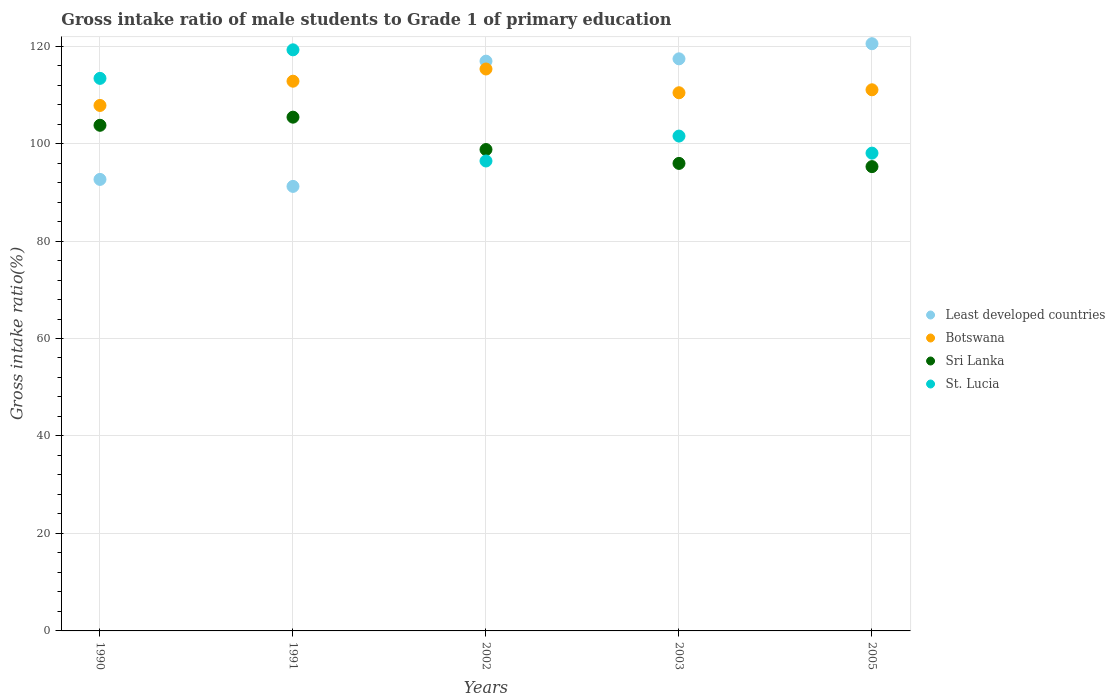How many different coloured dotlines are there?
Provide a succinct answer. 4. Is the number of dotlines equal to the number of legend labels?
Your answer should be very brief. Yes. What is the gross intake ratio in Sri Lanka in 1991?
Your answer should be compact. 105.41. Across all years, what is the maximum gross intake ratio in St. Lucia?
Make the answer very short. 119.23. Across all years, what is the minimum gross intake ratio in St. Lucia?
Provide a succinct answer. 96.42. In which year was the gross intake ratio in St. Lucia maximum?
Ensure brevity in your answer.  1991. In which year was the gross intake ratio in Sri Lanka minimum?
Ensure brevity in your answer.  2005. What is the total gross intake ratio in Sri Lanka in the graph?
Provide a short and direct response. 499.13. What is the difference between the gross intake ratio in Sri Lanka in 2003 and that in 2005?
Offer a very short reply. 0.66. What is the difference between the gross intake ratio in Botswana in 1990 and the gross intake ratio in St. Lucia in 2005?
Give a very brief answer. 9.78. What is the average gross intake ratio in St. Lucia per year?
Your answer should be very brief. 105.72. In the year 1991, what is the difference between the gross intake ratio in Botswana and gross intake ratio in St. Lucia?
Provide a succinct answer. -6.44. What is the ratio of the gross intake ratio in Least developed countries in 1991 to that in 2002?
Your answer should be very brief. 0.78. Is the difference between the gross intake ratio in Botswana in 1990 and 1991 greater than the difference between the gross intake ratio in St. Lucia in 1990 and 1991?
Make the answer very short. Yes. What is the difference between the highest and the second highest gross intake ratio in Sri Lanka?
Provide a succinct answer. 1.67. What is the difference between the highest and the lowest gross intake ratio in St. Lucia?
Your answer should be very brief. 22.81. Is the sum of the gross intake ratio in Least developed countries in 2002 and 2003 greater than the maximum gross intake ratio in Botswana across all years?
Provide a short and direct response. Yes. What is the difference between two consecutive major ticks on the Y-axis?
Make the answer very short. 20. Does the graph contain grids?
Provide a succinct answer. Yes. Where does the legend appear in the graph?
Your response must be concise. Center right. How many legend labels are there?
Provide a short and direct response. 4. How are the legend labels stacked?
Keep it short and to the point. Vertical. What is the title of the graph?
Keep it short and to the point. Gross intake ratio of male students to Grade 1 of primary education. Does "Dominican Republic" appear as one of the legend labels in the graph?
Provide a succinct answer. No. What is the label or title of the Y-axis?
Keep it short and to the point. Gross intake ratio(%). What is the Gross intake ratio(%) of Least developed countries in 1990?
Provide a succinct answer. 92.64. What is the Gross intake ratio(%) in Botswana in 1990?
Give a very brief answer. 107.82. What is the Gross intake ratio(%) in Sri Lanka in 1990?
Make the answer very short. 103.75. What is the Gross intake ratio(%) in St. Lucia in 1990?
Provide a short and direct response. 113.38. What is the Gross intake ratio(%) in Least developed countries in 1991?
Ensure brevity in your answer.  91.21. What is the Gross intake ratio(%) of Botswana in 1991?
Provide a short and direct response. 112.8. What is the Gross intake ratio(%) in Sri Lanka in 1991?
Offer a terse response. 105.41. What is the Gross intake ratio(%) in St. Lucia in 1991?
Your answer should be compact. 119.23. What is the Gross intake ratio(%) in Least developed countries in 2002?
Offer a very short reply. 116.91. What is the Gross intake ratio(%) of Botswana in 2002?
Your answer should be very brief. 115.3. What is the Gross intake ratio(%) of Sri Lanka in 2002?
Provide a succinct answer. 98.77. What is the Gross intake ratio(%) in St. Lucia in 2002?
Ensure brevity in your answer.  96.42. What is the Gross intake ratio(%) in Least developed countries in 2003?
Provide a succinct answer. 117.39. What is the Gross intake ratio(%) of Botswana in 2003?
Provide a succinct answer. 110.42. What is the Gross intake ratio(%) in Sri Lanka in 2003?
Your response must be concise. 95.93. What is the Gross intake ratio(%) of St. Lucia in 2003?
Ensure brevity in your answer.  101.53. What is the Gross intake ratio(%) of Least developed countries in 2005?
Offer a very short reply. 120.49. What is the Gross intake ratio(%) of Botswana in 2005?
Ensure brevity in your answer.  111.03. What is the Gross intake ratio(%) of Sri Lanka in 2005?
Your response must be concise. 95.27. What is the Gross intake ratio(%) in St. Lucia in 2005?
Your answer should be very brief. 98.04. Across all years, what is the maximum Gross intake ratio(%) in Least developed countries?
Give a very brief answer. 120.49. Across all years, what is the maximum Gross intake ratio(%) of Botswana?
Your answer should be compact. 115.3. Across all years, what is the maximum Gross intake ratio(%) of Sri Lanka?
Your answer should be compact. 105.41. Across all years, what is the maximum Gross intake ratio(%) in St. Lucia?
Keep it short and to the point. 119.23. Across all years, what is the minimum Gross intake ratio(%) in Least developed countries?
Make the answer very short. 91.21. Across all years, what is the minimum Gross intake ratio(%) in Botswana?
Offer a very short reply. 107.82. Across all years, what is the minimum Gross intake ratio(%) in Sri Lanka?
Your answer should be very brief. 95.27. Across all years, what is the minimum Gross intake ratio(%) in St. Lucia?
Provide a succinct answer. 96.42. What is the total Gross intake ratio(%) in Least developed countries in the graph?
Keep it short and to the point. 538.64. What is the total Gross intake ratio(%) of Botswana in the graph?
Provide a short and direct response. 557.37. What is the total Gross intake ratio(%) in Sri Lanka in the graph?
Ensure brevity in your answer.  499.13. What is the total Gross intake ratio(%) in St. Lucia in the graph?
Offer a very short reply. 528.6. What is the difference between the Gross intake ratio(%) in Least developed countries in 1990 and that in 1991?
Give a very brief answer. 1.43. What is the difference between the Gross intake ratio(%) of Botswana in 1990 and that in 1991?
Offer a very short reply. -4.98. What is the difference between the Gross intake ratio(%) in Sri Lanka in 1990 and that in 1991?
Provide a succinct answer. -1.67. What is the difference between the Gross intake ratio(%) of St. Lucia in 1990 and that in 1991?
Offer a very short reply. -5.85. What is the difference between the Gross intake ratio(%) of Least developed countries in 1990 and that in 2002?
Your answer should be very brief. -24.26. What is the difference between the Gross intake ratio(%) in Botswana in 1990 and that in 2002?
Ensure brevity in your answer.  -7.48. What is the difference between the Gross intake ratio(%) of Sri Lanka in 1990 and that in 2002?
Offer a terse response. 4.97. What is the difference between the Gross intake ratio(%) in St. Lucia in 1990 and that in 2002?
Offer a very short reply. 16.95. What is the difference between the Gross intake ratio(%) of Least developed countries in 1990 and that in 2003?
Keep it short and to the point. -24.74. What is the difference between the Gross intake ratio(%) in Botswana in 1990 and that in 2003?
Your answer should be very brief. -2.6. What is the difference between the Gross intake ratio(%) of Sri Lanka in 1990 and that in 2003?
Your answer should be very brief. 7.82. What is the difference between the Gross intake ratio(%) of St. Lucia in 1990 and that in 2003?
Offer a very short reply. 11.84. What is the difference between the Gross intake ratio(%) of Least developed countries in 1990 and that in 2005?
Provide a short and direct response. -27.84. What is the difference between the Gross intake ratio(%) in Botswana in 1990 and that in 2005?
Provide a succinct answer. -3.21. What is the difference between the Gross intake ratio(%) in Sri Lanka in 1990 and that in 2005?
Your answer should be compact. 8.48. What is the difference between the Gross intake ratio(%) in St. Lucia in 1990 and that in 2005?
Offer a terse response. 15.34. What is the difference between the Gross intake ratio(%) in Least developed countries in 1991 and that in 2002?
Provide a short and direct response. -25.69. What is the difference between the Gross intake ratio(%) of Botswana in 1991 and that in 2002?
Give a very brief answer. -2.51. What is the difference between the Gross intake ratio(%) in Sri Lanka in 1991 and that in 2002?
Offer a terse response. 6.64. What is the difference between the Gross intake ratio(%) of St. Lucia in 1991 and that in 2002?
Offer a terse response. 22.81. What is the difference between the Gross intake ratio(%) in Least developed countries in 1991 and that in 2003?
Ensure brevity in your answer.  -26.17. What is the difference between the Gross intake ratio(%) of Botswana in 1991 and that in 2003?
Give a very brief answer. 2.37. What is the difference between the Gross intake ratio(%) of Sri Lanka in 1991 and that in 2003?
Offer a terse response. 9.49. What is the difference between the Gross intake ratio(%) in St. Lucia in 1991 and that in 2003?
Your answer should be very brief. 17.7. What is the difference between the Gross intake ratio(%) of Least developed countries in 1991 and that in 2005?
Give a very brief answer. -29.28. What is the difference between the Gross intake ratio(%) of Botswana in 1991 and that in 2005?
Offer a terse response. 1.76. What is the difference between the Gross intake ratio(%) in Sri Lanka in 1991 and that in 2005?
Your answer should be very brief. 10.15. What is the difference between the Gross intake ratio(%) of St. Lucia in 1991 and that in 2005?
Provide a short and direct response. 21.19. What is the difference between the Gross intake ratio(%) of Least developed countries in 2002 and that in 2003?
Your answer should be very brief. -0.48. What is the difference between the Gross intake ratio(%) in Botswana in 2002 and that in 2003?
Provide a succinct answer. 4.88. What is the difference between the Gross intake ratio(%) in Sri Lanka in 2002 and that in 2003?
Provide a succinct answer. 2.85. What is the difference between the Gross intake ratio(%) in St. Lucia in 2002 and that in 2003?
Make the answer very short. -5.11. What is the difference between the Gross intake ratio(%) of Least developed countries in 2002 and that in 2005?
Provide a succinct answer. -3.58. What is the difference between the Gross intake ratio(%) in Botswana in 2002 and that in 2005?
Keep it short and to the point. 4.27. What is the difference between the Gross intake ratio(%) of Sri Lanka in 2002 and that in 2005?
Your response must be concise. 3.51. What is the difference between the Gross intake ratio(%) of St. Lucia in 2002 and that in 2005?
Make the answer very short. -1.61. What is the difference between the Gross intake ratio(%) in Least developed countries in 2003 and that in 2005?
Your answer should be compact. -3.1. What is the difference between the Gross intake ratio(%) in Botswana in 2003 and that in 2005?
Offer a terse response. -0.61. What is the difference between the Gross intake ratio(%) in Sri Lanka in 2003 and that in 2005?
Ensure brevity in your answer.  0.66. What is the difference between the Gross intake ratio(%) in St. Lucia in 2003 and that in 2005?
Provide a short and direct response. 3.5. What is the difference between the Gross intake ratio(%) in Least developed countries in 1990 and the Gross intake ratio(%) in Botswana in 1991?
Offer a terse response. -20.15. What is the difference between the Gross intake ratio(%) in Least developed countries in 1990 and the Gross intake ratio(%) in Sri Lanka in 1991?
Ensure brevity in your answer.  -12.77. What is the difference between the Gross intake ratio(%) of Least developed countries in 1990 and the Gross intake ratio(%) of St. Lucia in 1991?
Your answer should be very brief. -26.59. What is the difference between the Gross intake ratio(%) of Botswana in 1990 and the Gross intake ratio(%) of Sri Lanka in 1991?
Your response must be concise. 2.41. What is the difference between the Gross intake ratio(%) of Botswana in 1990 and the Gross intake ratio(%) of St. Lucia in 1991?
Your response must be concise. -11.41. What is the difference between the Gross intake ratio(%) of Sri Lanka in 1990 and the Gross intake ratio(%) of St. Lucia in 1991?
Offer a very short reply. -15.48. What is the difference between the Gross intake ratio(%) of Least developed countries in 1990 and the Gross intake ratio(%) of Botswana in 2002?
Ensure brevity in your answer.  -22.66. What is the difference between the Gross intake ratio(%) of Least developed countries in 1990 and the Gross intake ratio(%) of Sri Lanka in 2002?
Keep it short and to the point. -6.13. What is the difference between the Gross intake ratio(%) in Least developed countries in 1990 and the Gross intake ratio(%) in St. Lucia in 2002?
Ensure brevity in your answer.  -3.78. What is the difference between the Gross intake ratio(%) of Botswana in 1990 and the Gross intake ratio(%) of Sri Lanka in 2002?
Offer a terse response. 9.04. What is the difference between the Gross intake ratio(%) in Botswana in 1990 and the Gross intake ratio(%) in St. Lucia in 2002?
Ensure brevity in your answer.  11.4. What is the difference between the Gross intake ratio(%) in Sri Lanka in 1990 and the Gross intake ratio(%) in St. Lucia in 2002?
Provide a succinct answer. 7.32. What is the difference between the Gross intake ratio(%) of Least developed countries in 1990 and the Gross intake ratio(%) of Botswana in 2003?
Offer a very short reply. -17.78. What is the difference between the Gross intake ratio(%) of Least developed countries in 1990 and the Gross intake ratio(%) of Sri Lanka in 2003?
Make the answer very short. -3.29. What is the difference between the Gross intake ratio(%) in Least developed countries in 1990 and the Gross intake ratio(%) in St. Lucia in 2003?
Offer a terse response. -8.89. What is the difference between the Gross intake ratio(%) of Botswana in 1990 and the Gross intake ratio(%) of Sri Lanka in 2003?
Ensure brevity in your answer.  11.89. What is the difference between the Gross intake ratio(%) in Botswana in 1990 and the Gross intake ratio(%) in St. Lucia in 2003?
Make the answer very short. 6.29. What is the difference between the Gross intake ratio(%) in Sri Lanka in 1990 and the Gross intake ratio(%) in St. Lucia in 2003?
Ensure brevity in your answer.  2.21. What is the difference between the Gross intake ratio(%) in Least developed countries in 1990 and the Gross intake ratio(%) in Botswana in 2005?
Ensure brevity in your answer.  -18.39. What is the difference between the Gross intake ratio(%) of Least developed countries in 1990 and the Gross intake ratio(%) of Sri Lanka in 2005?
Your answer should be very brief. -2.62. What is the difference between the Gross intake ratio(%) in Least developed countries in 1990 and the Gross intake ratio(%) in St. Lucia in 2005?
Make the answer very short. -5.39. What is the difference between the Gross intake ratio(%) in Botswana in 1990 and the Gross intake ratio(%) in Sri Lanka in 2005?
Your answer should be very brief. 12.55. What is the difference between the Gross intake ratio(%) in Botswana in 1990 and the Gross intake ratio(%) in St. Lucia in 2005?
Provide a short and direct response. 9.78. What is the difference between the Gross intake ratio(%) in Sri Lanka in 1990 and the Gross intake ratio(%) in St. Lucia in 2005?
Offer a terse response. 5.71. What is the difference between the Gross intake ratio(%) of Least developed countries in 1991 and the Gross intake ratio(%) of Botswana in 2002?
Your answer should be very brief. -24.09. What is the difference between the Gross intake ratio(%) in Least developed countries in 1991 and the Gross intake ratio(%) in Sri Lanka in 2002?
Provide a short and direct response. -7.56. What is the difference between the Gross intake ratio(%) in Least developed countries in 1991 and the Gross intake ratio(%) in St. Lucia in 2002?
Provide a succinct answer. -5.21. What is the difference between the Gross intake ratio(%) of Botswana in 1991 and the Gross intake ratio(%) of Sri Lanka in 2002?
Make the answer very short. 14.02. What is the difference between the Gross intake ratio(%) in Botswana in 1991 and the Gross intake ratio(%) in St. Lucia in 2002?
Offer a very short reply. 16.37. What is the difference between the Gross intake ratio(%) of Sri Lanka in 1991 and the Gross intake ratio(%) of St. Lucia in 2002?
Ensure brevity in your answer.  8.99. What is the difference between the Gross intake ratio(%) in Least developed countries in 1991 and the Gross intake ratio(%) in Botswana in 2003?
Offer a very short reply. -19.21. What is the difference between the Gross intake ratio(%) of Least developed countries in 1991 and the Gross intake ratio(%) of Sri Lanka in 2003?
Offer a terse response. -4.72. What is the difference between the Gross intake ratio(%) of Least developed countries in 1991 and the Gross intake ratio(%) of St. Lucia in 2003?
Offer a very short reply. -10.32. What is the difference between the Gross intake ratio(%) of Botswana in 1991 and the Gross intake ratio(%) of Sri Lanka in 2003?
Ensure brevity in your answer.  16.87. What is the difference between the Gross intake ratio(%) of Botswana in 1991 and the Gross intake ratio(%) of St. Lucia in 2003?
Keep it short and to the point. 11.26. What is the difference between the Gross intake ratio(%) of Sri Lanka in 1991 and the Gross intake ratio(%) of St. Lucia in 2003?
Make the answer very short. 3.88. What is the difference between the Gross intake ratio(%) in Least developed countries in 1991 and the Gross intake ratio(%) in Botswana in 2005?
Your response must be concise. -19.82. What is the difference between the Gross intake ratio(%) of Least developed countries in 1991 and the Gross intake ratio(%) of Sri Lanka in 2005?
Make the answer very short. -4.06. What is the difference between the Gross intake ratio(%) of Least developed countries in 1991 and the Gross intake ratio(%) of St. Lucia in 2005?
Your answer should be very brief. -6.83. What is the difference between the Gross intake ratio(%) of Botswana in 1991 and the Gross intake ratio(%) of Sri Lanka in 2005?
Offer a terse response. 17.53. What is the difference between the Gross intake ratio(%) in Botswana in 1991 and the Gross intake ratio(%) in St. Lucia in 2005?
Offer a very short reply. 14.76. What is the difference between the Gross intake ratio(%) in Sri Lanka in 1991 and the Gross intake ratio(%) in St. Lucia in 2005?
Offer a terse response. 7.38. What is the difference between the Gross intake ratio(%) in Least developed countries in 2002 and the Gross intake ratio(%) in Botswana in 2003?
Provide a succinct answer. 6.48. What is the difference between the Gross intake ratio(%) of Least developed countries in 2002 and the Gross intake ratio(%) of Sri Lanka in 2003?
Provide a succinct answer. 20.98. What is the difference between the Gross intake ratio(%) in Least developed countries in 2002 and the Gross intake ratio(%) in St. Lucia in 2003?
Provide a short and direct response. 15.37. What is the difference between the Gross intake ratio(%) in Botswana in 2002 and the Gross intake ratio(%) in Sri Lanka in 2003?
Provide a short and direct response. 19.37. What is the difference between the Gross intake ratio(%) in Botswana in 2002 and the Gross intake ratio(%) in St. Lucia in 2003?
Keep it short and to the point. 13.77. What is the difference between the Gross intake ratio(%) in Sri Lanka in 2002 and the Gross intake ratio(%) in St. Lucia in 2003?
Make the answer very short. -2.76. What is the difference between the Gross intake ratio(%) in Least developed countries in 2002 and the Gross intake ratio(%) in Botswana in 2005?
Offer a very short reply. 5.87. What is the difference between the Gross intake ratio(%) in Least developed countries in 2002 and the Gross intake ratio(%) in Sri Lanka in 2005?
Give a very brief answer. 21.64. What is the difference between the Gross intake ratio(%) in Least developed countries in 2002 and the Gross intake ratio(%) in St. Lucia in 2005?
Ensure brevity in your answer.  18.87. What is the difference between the Gross intake ratio(%) of Botswana in 2002 and the Gross intake ratio(%) of Sri Lanka in 2005?
Ensure brevity in your answer.  20.03. What is the difference between the Gross intake ratio(%) in Botswana in 2002 and the Gross intake ratio(%) in St. Lucia in 2005?
Provide a succinct answer. 17.26. What is the difference between the Gross intake ratio(%) of Sri Lanka in 2002 and the Gross intake ratio(%) of St. Lucia in 2005?
Keep it short and to the point. 0.74. What is the difference between the Gross intake ratio(%) of Least developed countries in 2003 and the Gross intake ratio(%) of Botswana in 2005?
Ensure brevity in your answer.  6.35. What is the difference between the Gross intake ratio(%) in Least developed countries in 2003 and the Gross intake ratio(%) in Sri Lanka in 2005?
Provide a short and direct response. 22.12. What is the difference between the Gross intake ratio(%) in Least developed countries in 2003 and the Gross intake ratio(%) in St. Lucia in 2005?
Your response must be concise. 19.35. What is the difference between the Gross intake ratio(%) of Botswana in 2003 and the Gross intake ratio(%) of Sri Lanka in 2005?
Keep it short and to the point. 15.16. What is the difference between the Gross intake ratio(%) in Botswana in 2003 and the Gross intake ratio(%) in St. Lucia in 2005?
Offer a very short reply. 12.39. What is the difference between the Gross intake ratio(%) of Sri Lanka in 2003 and the Gross intake ratio(%) of St. Lucia in 2005?
Your answer should be very brief. -2.11. What is the average Gross intake ratio(%) in Least developed countries per year?
Offer a terse response. 107.73. What is the average Gross intake ratio(%) of Botswana per year?
Your answer should be very brief. 111.47. What is the average Gross intake ratio(%) in Sri Lanka per year?
Your answer should be compact. 99.83. What is the average Gross intake ratio(%) of St. Lucia per year?
Your answer should be very brief. 105.72. In the year 1990, what is the difference between the Gross intake ratio(%) of Least developed countries and Gross intake ratio(%) of Botswana?
Your response must be concise. -15.18. In the year 1990, what is the difference between the Gross intake ratio(%) of Least developed countries and Gross intake ratio(%) of Sri Lanka?
Provide a short and direct response. -11.1. In the year 1990, what is the difference between the Gross intake ratio(%) in Least developed countries and Gross intake ratio(%) in St. Lucia?
Your answer should be compact. -20.73. In the year 1990, what is the difference between the Gross intake ratio(%) of Botswana and Gross intake ratio(%) of Sri Lanka?
Offer a terse response. 4.07. In the year 1990, what is the difference between the Gross intake ratio(%) in Botswana and Gross intake ratio(%) in St. Lucia?
Provide a short and direct response. -5.56. In the year 1990, what is the difference between the Gross intake ratio(%) in Sri Lanka and Gross intake ratio(%) in St. Lucia?
Provide a succinct answer. -9.63. In the year 1991, what is the difference between the Gross intake ratio(%) in Least developed countries and Gross intake ratio(%) in Botswana?
Provide a succinct answer. -21.58. In the year 1991, what is the difference between the Gross intake ratio(%) in Least developed countries and Gross intake ratio(%) in Sri Lanka?
Keep it short and to the point. -14.2. In the year 1991, what is the difference between the Gross intake ratio(%) of Least developed countries and Gross intake ratio(%) of St. Lucia?
Give a very brief answer. -28.02. In the year 1991, what is the difference between the Gross intake ratio(%) in Botswana and Gross intake ratio(%) in Sri Lanka?
Give a very brief answer. 7.38. In the year 1991, what is the difference between the Gross intake ratio(%) in Botswana and Gross intake ratio(%) in St. Lucia?
Make the answer very short. -6.44. In the year 1991, what is the difference between the Gross intake ratio(%) in Sri Lanka and Gross intake ratio(%) in St. Lucia?
Provide a succinct answer. -13.82. In the year 2002, what is the difference between the Gross intake ratio(%) of Least developed countries and Gross intake ratio(%) of Botswana?
Offer a very short reply. 1.6. In the year 2002, what is the difference between the Gross intake ratio(%) of Least developed countries and Gross intake ratio(%) of Sri Lanka?
Ensure brevity in your answer.  18.13. In the year 2002, what is the difference between the Gross intake ratio(%) of Least developed countries and Gross intake ratio(%) of St. Lucia?
Offer a terse response. 20.48. In the year 2002, what is the difference between the Gross intake ratio(%) in Botswana and Gross intake ratio(%) in Sri Lanka?
Give a very brief answer. 16.53. In the year 2002, what is the difference between the Gross intake ratio(%) in Botswana and Gross intake ratio(%) in St. Lucia?
Your response must be concise. 18.88. In the year 2002, what is the difference between the Gross intake ratio(%) of Sri Lanka and Gross intake ratio(%) of St. Lucia?
Offer a very short reply. 2.35. In the year 2003, what is the difference between the Gross intake ratio(%) of Least developed countries and Gross intake ratio(%) of Botswana?
Provide a succinct answer. 6.96. In the year 2003, what is the difference between the Gross intake ratio(%) of Least developed countries and Gross intake ratio(%) of Sri Lanka?
Your response must be concise. 21.46. In the year 2003, what is the difference between the Gross intake ratio(%) of Least developed countries and Gross intake ratio(%) of St. Lucia?
Make the answer very short. 15.85. In the year 2003, what is the difference between the Gross intake ratio(%) of Botswana and Gross intake ratio(%) of Sri Lanka?
Provide a succinct answer. 14.5. In the year 2003, what is the difference between the Gross intake ratio(%) in Botswana and Gross intake ratio(%) in St. Lucia?
Give a very brief answer. 8.89. In the year 2003, what is the difference between the Gross intake ratio(%) in Sri Lanka and Gross intake ratio(%) in St. Lucia?
Offer a terse response. -5.61. In the year 2005, what is the difference between the Gross intake ratio(%) in Least developed countries and Gross intake ratio(%) in Botswana?
Your answer should be very brief. 9.46. In the year 2005, what is the difference between the Gross intake ratio(%) in Least developed countries and Gross intake ratio(%) in Sri Lanka?
Give a very brief answer. 25.22. In the year 2005, what is the difference between the Gross intake ratio(%) in Least developed countries and Gross intake ratio(%) in St. Lucia?
Give a very brief answer. 22.45. In the year 2005, what is the difference between the Gross intake ratio(%) of Botswana and Gross intake ratio(%) of Sri Lanka?
Provide a short and direct response. 15.77. In the year 2005, what is the difference between the Gross intake ratio(%) in Botswana and Gross intake ratio(%) in St. Lucia?
Offer a very short reply. 13. In the year 2005, what is the difference between the Gross intake ratio(%) of Sri Lanka and Gross intake ratio(%) of St. Lucia?
Offer a terse response. -2.77. What is the ratio of the Gross intake ratio(%) in Least developed countries in 1990 to that in 1991?
Provide a succinct answer. 1.02. What is the ratio of the Gross intake ratio(%) in Botswana in 1990 to that in 1991?
Your answer should be very brief. 0.96. What is the ratio of the Gross intake ratio(%) in Sri Lanka in 1990 to that in 1991?
Ensure brevity in your answer.  0.98. What is the ratio of the Gross intake ratio(%) of St. Lucia in 1990 to that in 1991?
Provide a succinct answer. 0.95. What is the ratio of the Gross intake ratio(%) in Least developed countries in 1990 to that in 2002?
Ensure brevity in your answer.  0.79. What is the ratio of the Gross intake ratio(%) of Botswana in 1990 to that in 2002?
Give a very brief answer. 0.94. What is the ratio of the Gross intake ratio(%) in Sri Lanka in 1990 to that in 2002?
Keep it short and to the point. 1.05. What is the ratio of the Gross intake ratio(%) of St. Lucia in 1990 to that in 2002?
Your response must be concise. 1.18. What is the ratio of the Gross intake ratio(%) of Least developed countries in 1990 to that in 2003?
Your response must be concise. 0.79. What is the ratio of the Gross intake ratio(%) in Botswana in 1990 to that in 2003?
Your response must be concise. 0.98. What is the ratio of the Gross intake ratio(%) in Sri Lanka in 1990 to that in 2003?
Ensure brevity in your answer.  1.08. What is the ratio of the Gross intake ratio(%) in St. Lucia in 1990 to that in 2003?
Keep it short and to the point. 1.12. What is the ratio of the Gross intake ratio(%) of Least developed countries in 1990 to that in 2005?
Provide a succinct answer. 0.77. What is the ratio of the Gross intake ratio(%) in Botswana in 1990 to that in 2005?
Offer a very short reply. 0.97. What is the ratio of the Gross intake ratio(%) of Sri Lanka in 1990 to that in 2005?
Keep it short and to the point. 1.09. What is the ratio of the Gross intake ratio(%) of St. Lucia in 1990 to that in 2005?
Keep it short and to the point. 1.16. What is the ratio of the Gross intake ratio(%) in Least developed countries in 1991 to that in 2002?
Keep it short and to the point. 0.78. What is the ratio of the Gross intake ratio(%) in Botswana in 1991 to that in 2002?
Provide a succinct answer. 0.98. What is the ratio of the Gross intake ratio(%) of Sri Lanka in 1991 to that in 2002?
Your response must be concise. 1.07. What is the ratio of the Gross intake ratio(%) in St. Lucia in 1991 to that in 2002?
Offer a terse response. 1.24. What is the ratio of the Gross intake ratio(%) in Least developed countries in 1991 to that in 2003?
Your response must be concise. 0.78. What is the ratio of the Gross intake ratio(%) of Botswana in 1991 to that in 2003?
Your answer should be very brief. 1.02. What is the ratio of the Gross intake ratio(%) in Sri Lanka in 1991 to that in 2003?
Offer a very short reply. 1.1. What is the ratio of the Gross intake ratio(%) in St. Lucia in 1991 to that in 2003?
Provide a short and direct response. 1.17. What is the ratio of the Gross intake ratio(%) of Least developed countries in 1991 to that in 2005?
Keep it short and to the point. 0.76. What is the ratio of the Gross intake ratio(%) of Botswana in 1991 to that in 2005?
Offer a terse response. 1.02. What is the ratio of the Gross intake ratio(%) in Sri Lanka in 1991 to that in 2005?
Give a very brief answer. 1.11. What is the ratio of the Gross intake ratio(%) in St. Lucia in 1991 to that in 2005?
Keep it short and to the point. 1.22. What is the ratio of the Gross intake ratio(%) in Least developed countries in 2002 to that in 2003?
Offer a terse response. 1. What is the ratio of the Gross intake ratio(%) in Botswana in 2002 to that in 2003?
Give a very brief answer. 1.04. What is the ratio of the Gross intake ratio(%) in Sri Lanka in 2002 to that in 2003?
Ensure brevity in your answer.  1.03. What is the ratio of the Gross intake ratio(%) of St. Lucia in 2002 to that in 2003?
Make the answer very short. 0.95. What is the ratio of the Gross intake ratio(%) of Least developed countries in 2002 to that in 2005?
Keep it short and to the point. 0.97. What is the ratio of the Gross intake ratio(%) in Botswana in 2002 to that in 2005?
Your answer should be very brief. 1.04. What is the ratio of the Gross intake ratio(%) of Sri Lanka in 2002 to that in 2005?
Your answer should be compact. 1.04. What is the ratio of the Gross intake ratio(%) in St. Lucia in 2002 to that in 2005?
Give a very brief answer. 0.98. What is the ratio of the Gross intake ratio(%) in Least developed countries in 2003 to that in 2005?
Your answer should be compact. 0.97. What is the ratio of the Gross intake ratio(%) in Sri Lanka in 2003 to that in 2005?
Your response must be concise. 1.01. What is the ratio of the Gross intake ratio(%) of St. Lucia in 2003 to that in 2005?
Provide a succinct answer. 1.04. What is the difference between the highest and the second highest Gross intake ratio(%) in Least developed countries?
Keep it short and to the point. 3.1. What is the difference between the highest and the second highest Gross intake ratio(%) of Botswana?
Your response must be concise. 2.51. What is the difference between the highest and the second highest Gross intake ratio(%) in Sri Lanka?
Your response must be concise. 1.67. What is the difference between the highest and the second highest Gross intake ratio(%) in St. Lucia?
Provide a succinct answer. 5.85. What is the difference between the highest and the lowest Gross intake ratio(%) of Least developed countries?
Provide a short and direct response. 29.28. What is the difference between the highest and the lowest Gross intake ratio(%) of Botswana?
Offer a terse response. 7.48. What is the difference between the highest and the lowest Gross intake ratio(%) in Sri Lanka?
Give a very brief answer. 10.15. What is the difference between the highest and the lowest Gross intake ratio(%) of St. Lucia?
Ensure brevity in your answer.  22.81. 